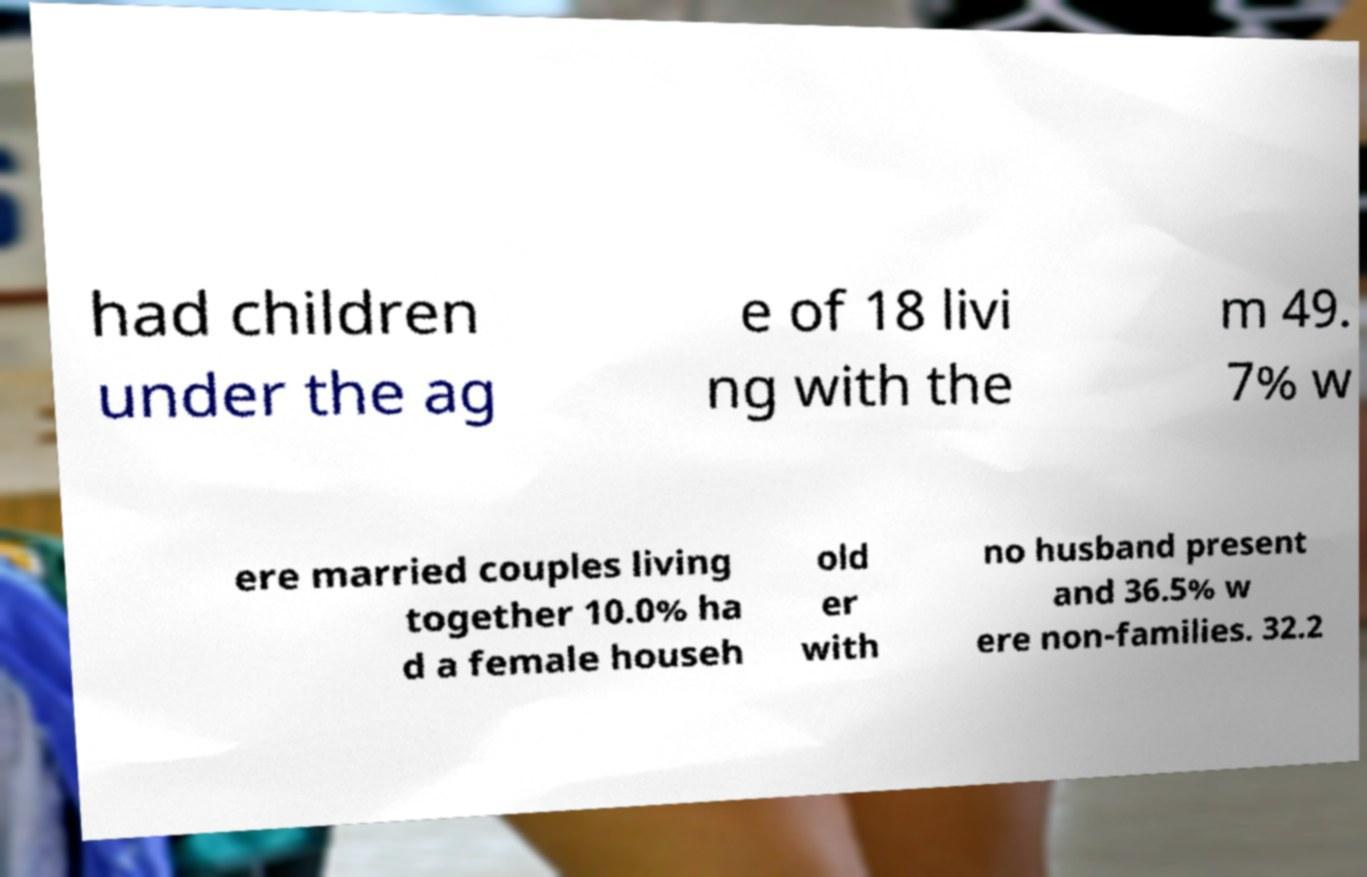For documentation purposes, I need the text within this image transcribed. Could you provide that? had children under the ag e of 18 livi ng with the m 49. 7% w ere married couples living together 10.0% ha d a female househ old er with no husband present and 36.5% w ere non-families. 32.2 